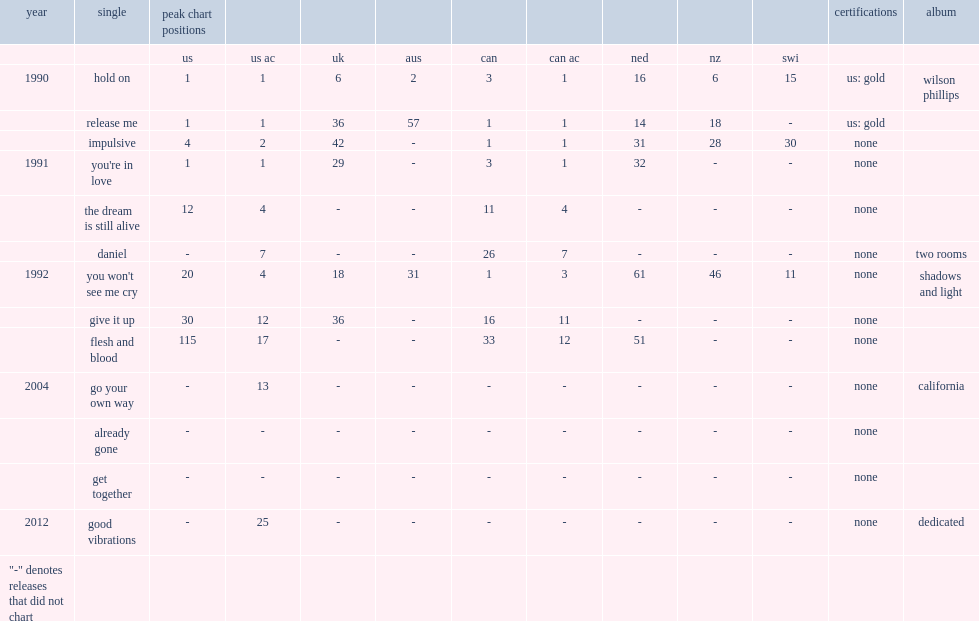When did the single "daniel" release? 1991.0. 